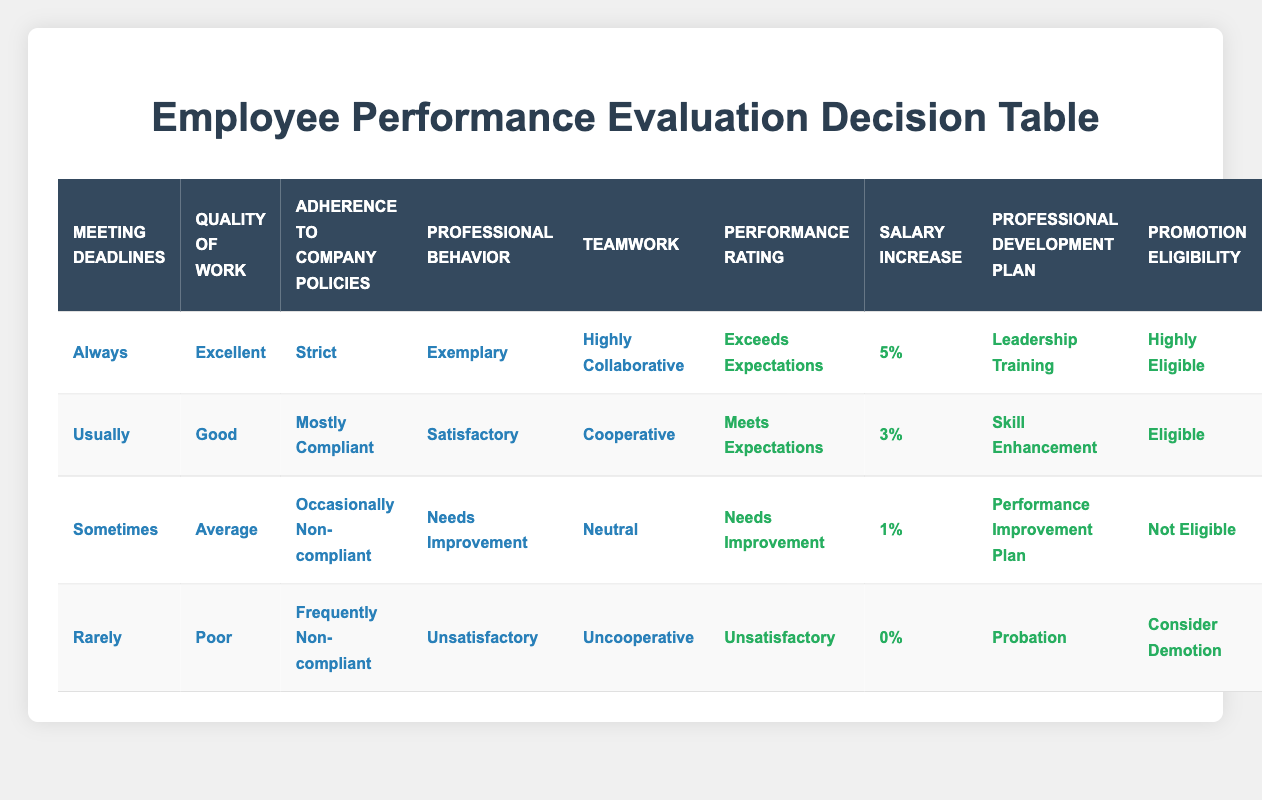What is the performance rating for employees who meet deadlines always and have excellent quality of work? Referring to the table, the conditions for "Always" in Meeting Deadlines and "Excellent" in Quality of Work directly lead to the action of "Exceeds Expectations" in Performance Rating.
Answer: Exceeds Expectations How many employees are eligible for a salary increase of 3%? From the table, only one scenario with "Usually" in Meeting Deadlines, "Good" in Quality of Work, and "Mostly Compliant" in Adherence to Company Policies results in a 3% salary increase.
Answer: 1 Is there any employee who has a performance rating of "Unsatisfactory"? Checking the table, we find that the condition for "Rarely" in Meeting Deadlines, "Poor" in Quality of Work, "Frequently Non-compliant" in Adherence to Company Policies, "Unsatisfactory" in Professional Behavior, and "Uncooperative" in Teamwork leads to an "Unsatisfactory" performance rating. Thus, there is at least one employee with this rating.
Answer: Yes What is the average salary increase for employees with a performance rating of "Needs Improvement"? There is one employee with "Needs Improvement" rated with a salary increase of 1%, which is the only applicable figure for this rating. Thus, the average salary increase would be just this value.
Answer: 1% What are the professional development plans for employees who are classified as "Not Eligible" for promotion? The table shows that employees with "Sometimes" in Meeting Deadlines, "Average" in Quality of Work, "Occasionally Non-compliant" in Adherence to Company Policies, and "Needs Improvement" in Professional Behavior are given a "Performance Improvement Plan" as the Professional Development Plan.
Answer: Performance Improvement Plan How many criteria must be met for an employee to be considered "Highly Eligible" for promotion? Looking at the "Highly Eligible" classification, it requires meeting five specific conditions: Meeting Deadlines "Always," Quality of Work "Excellent," Adherence to Company Policies "Strict," Professional Behavior "Exemplary," and Teamwork "Highly Collaborative." This indicates that all five criteria must be met for this rating.
Answer: All five criteria What is the salary increase for an employee who has "Rarely" met deadlines and shows "Poor" quality of work? From the table, the criteria of "Rarely" in Meeting Deadlines and "Poor" in Quality of Work corresponds to a salary increase of 0% due to unsatisfactory performance metrics alongside non-compliance.
Answer: 0% Is it true that having "Satisfactory" professional behavior always leads to a salary increase? A review of the performance ratings shows that "Satisfactory" professional behavior, which appears in the conditions for "Usually" in Meeting Deadlines, still leads to a salary increase of 3%. However, there's no guarantee that it leads to an increase in every scenario since it depends on combinations with other performance metrics.
Answer: No What is the minimum teamwork classification to receive a salary increase? The table specifies that with "Cooperative" in Teamwork, the employee qualifies for a salary increase of 3%, which is the lowest threshold to gain a salary increase in the evaluated conditions.
Answer: Cooperative 